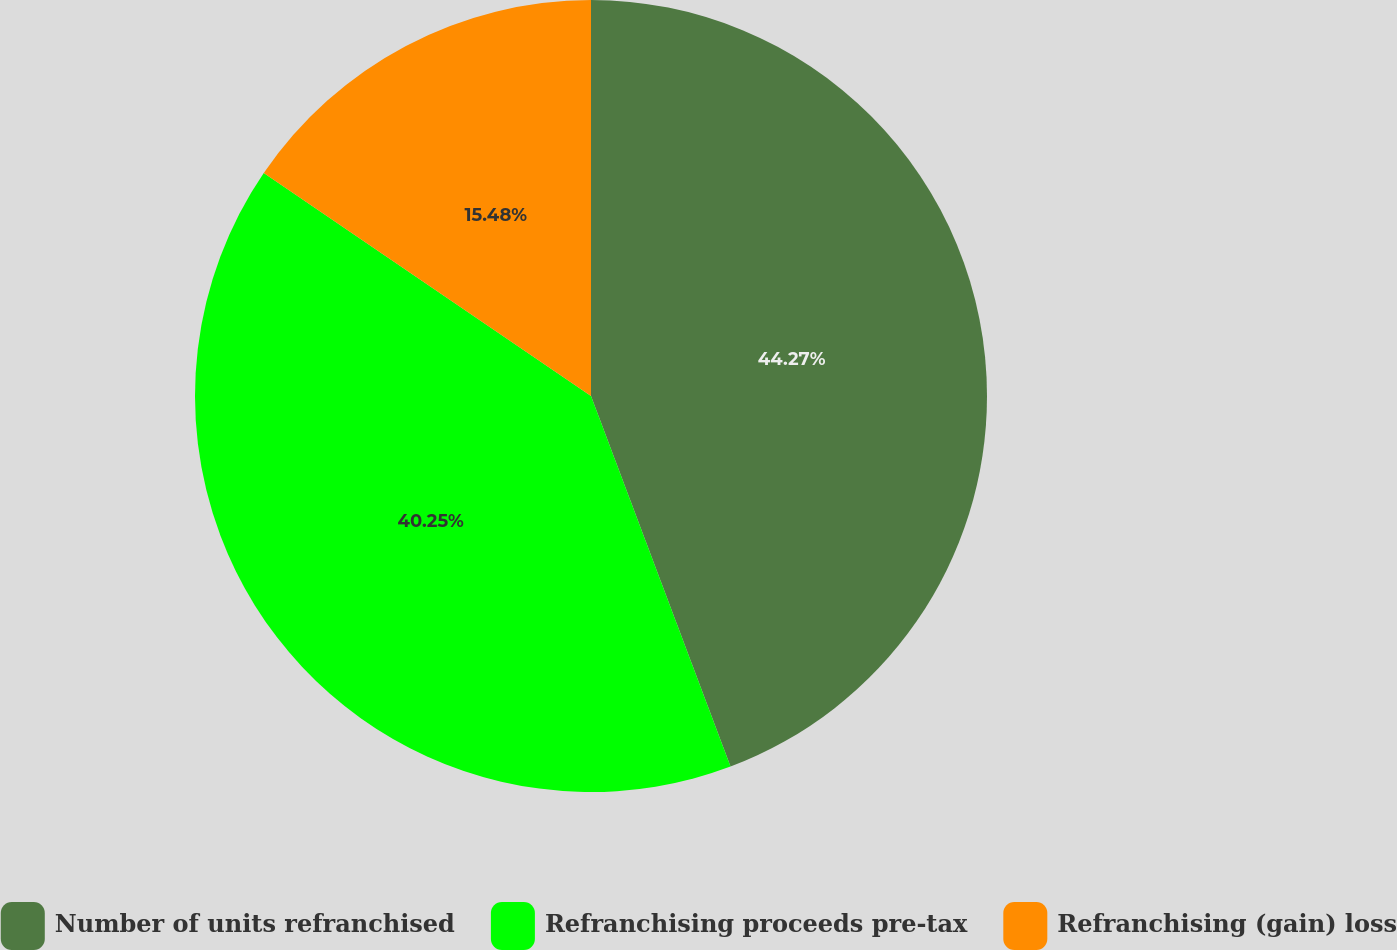Convert chart to OTSL. <chart><loc_0><loc_0><loc_500><loc_500><pie_chart><fcel>Number of units refranchised<fcel>Refranchising proceeds pre-tax<fcel>Refranchising (gain) loss<nl><fcel>44.27%<fcel>40.25%<fcel>15.48%<nl></chart> 